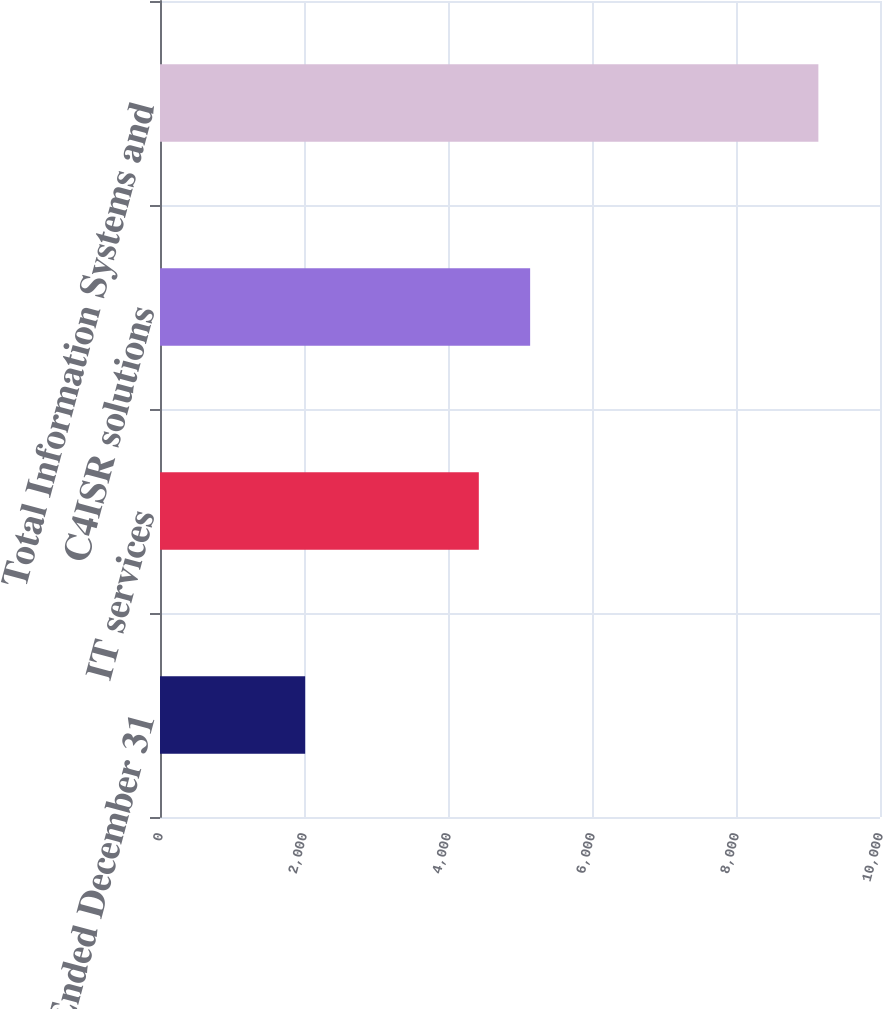Convert chart. <chart><loc_0><loc_0><loc_500><loc_500><bar_chart><fcel>Year Ended December 31<fcel>IT services<fcel>C4ISR solutions<fcel>Total Information Systems and<nl><fcel>2016<fcel>4428<fcel>5140.8<fcel>9144<nl></chart> 